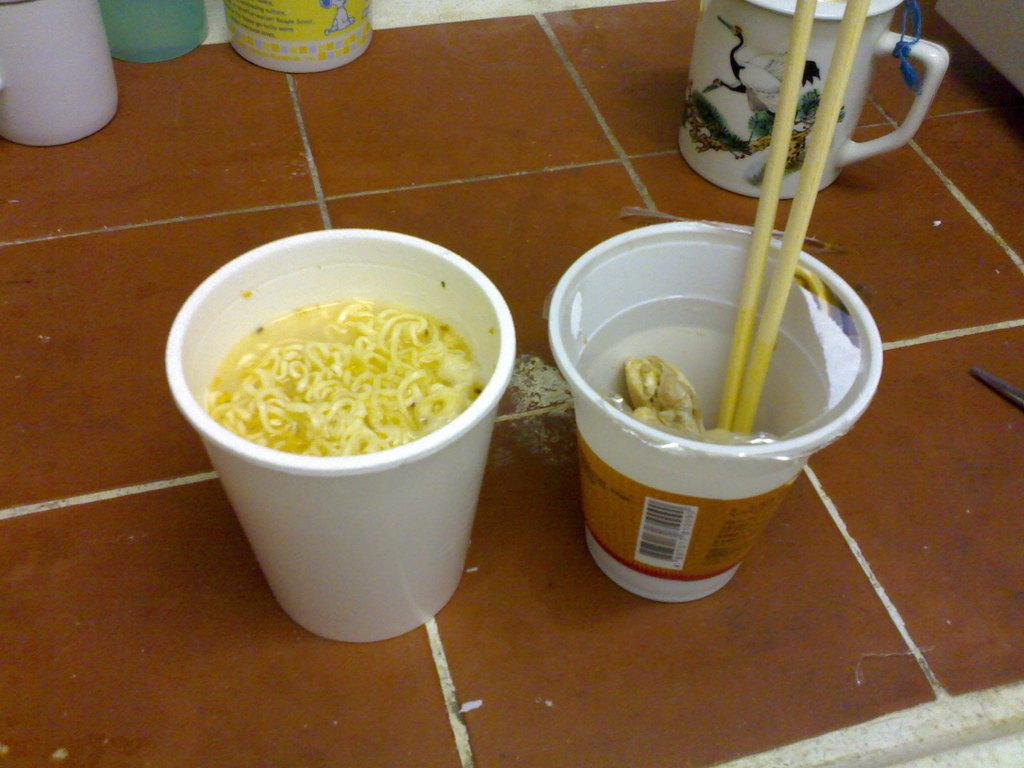What type of food is in the cup that is visible in the image? There is a cup of noodles in the image. What utensil is present in the other cup in the image? There is a cup with chopsticks in it in the image. Where are the cups located in the image? Both cups are on the floor in the image. What stage of development is the motion depicted in the image? There is no motion depicted in the image, as it features two cups on the floor. What emotion is the person in the image feeling as they regret their decision to eat the noodles? There is no person present in the image, and therefore no emotion or regret can be observed. 